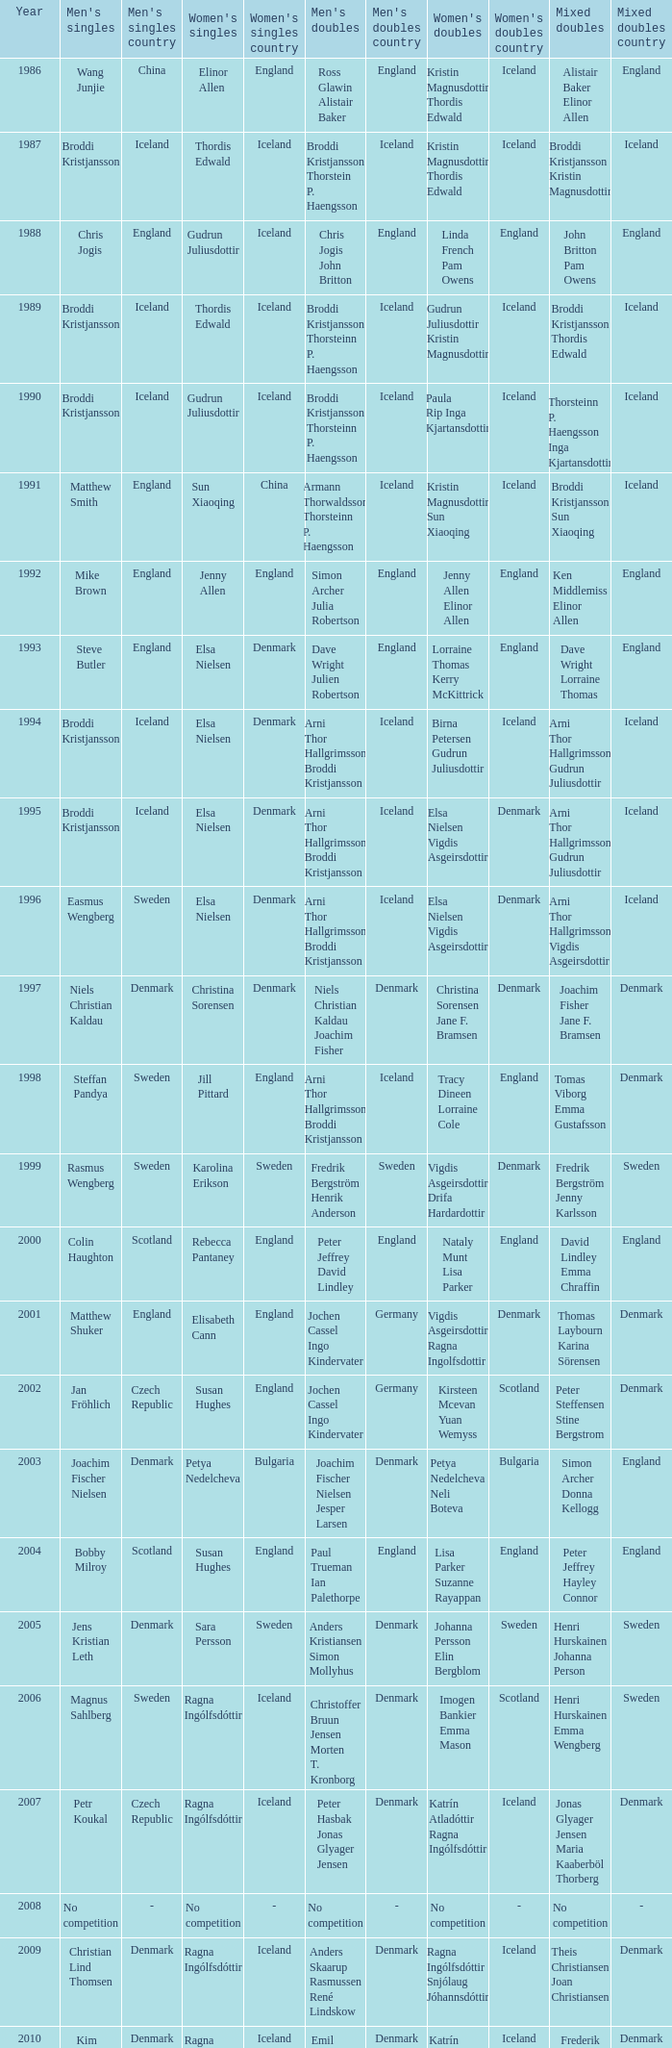In which women's doubles did Wang Junjie play men's singles? Kristin Magnusdottir Thordis Edwald. 